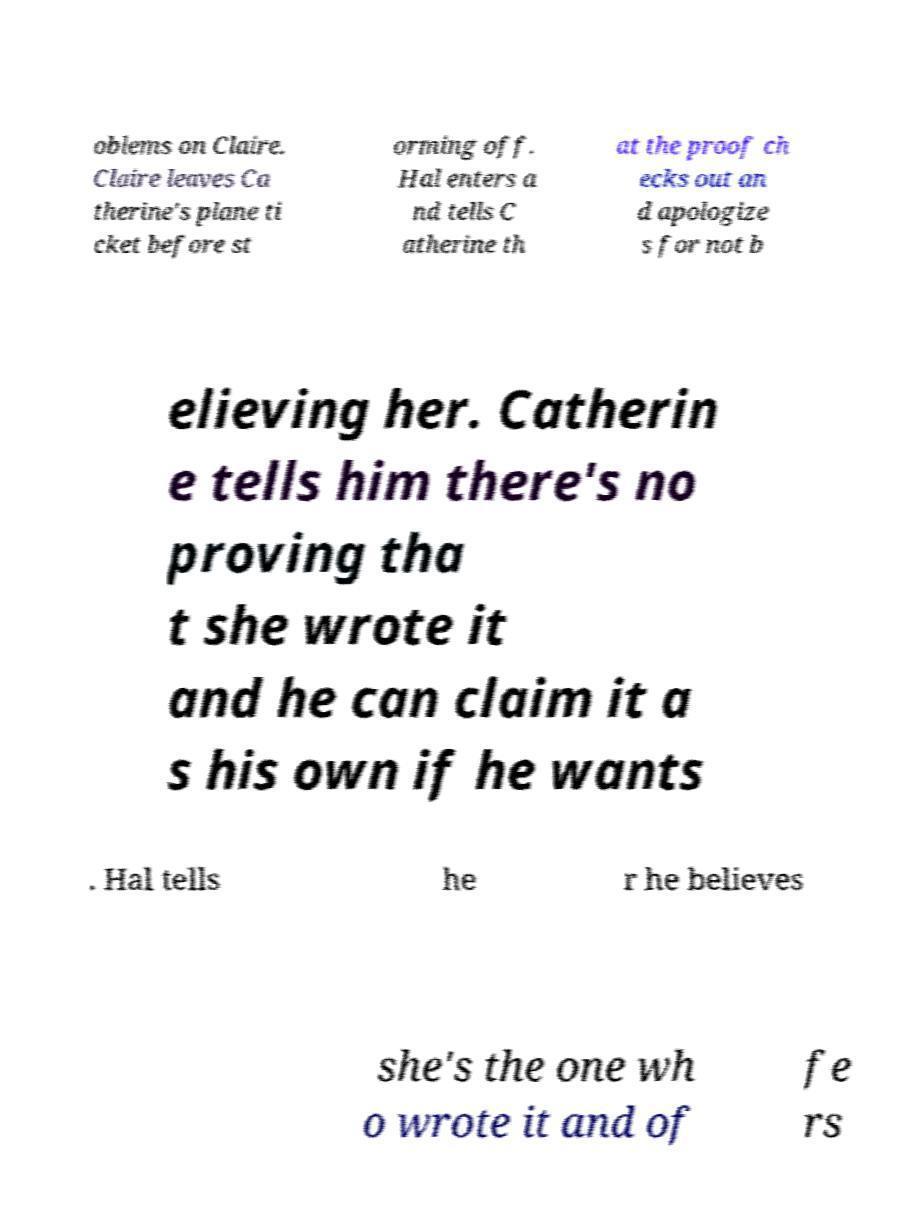Can you read and provide the text displayed in the image?This photo seems to have some interesting text. Can you extract and type it out for me? oblems on Claire. Claire leaves Ca therine's plane ti cket before st orming off. Hal enters a nd tells C atherine th at the proof ch ecks out an d apologize s for not b elieving her. Catherin e tells him there's no proving tha t she wrote it and he can claim it a s his own if he wants . Hal tells he r he believes she's the one wh o wrote it and of fe rs 